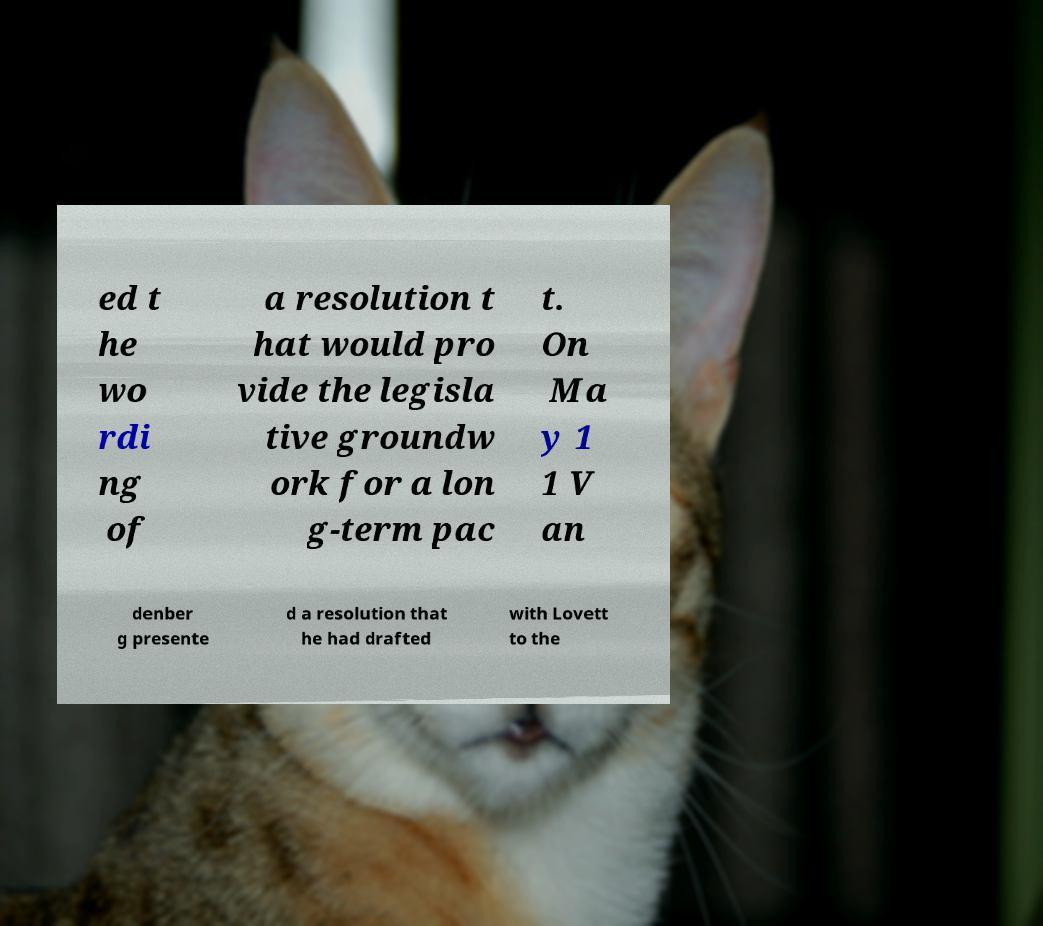Could you assist in decoding the text presented in this image and type it out clearly? ed t he wo rdi ng of a resolution t hat would pro vide the legisla tive groundw ork for a lon g-term pac t. On Ma y 1 1 V an denber g presente d a resolution that he had drafted with Lovett to the 